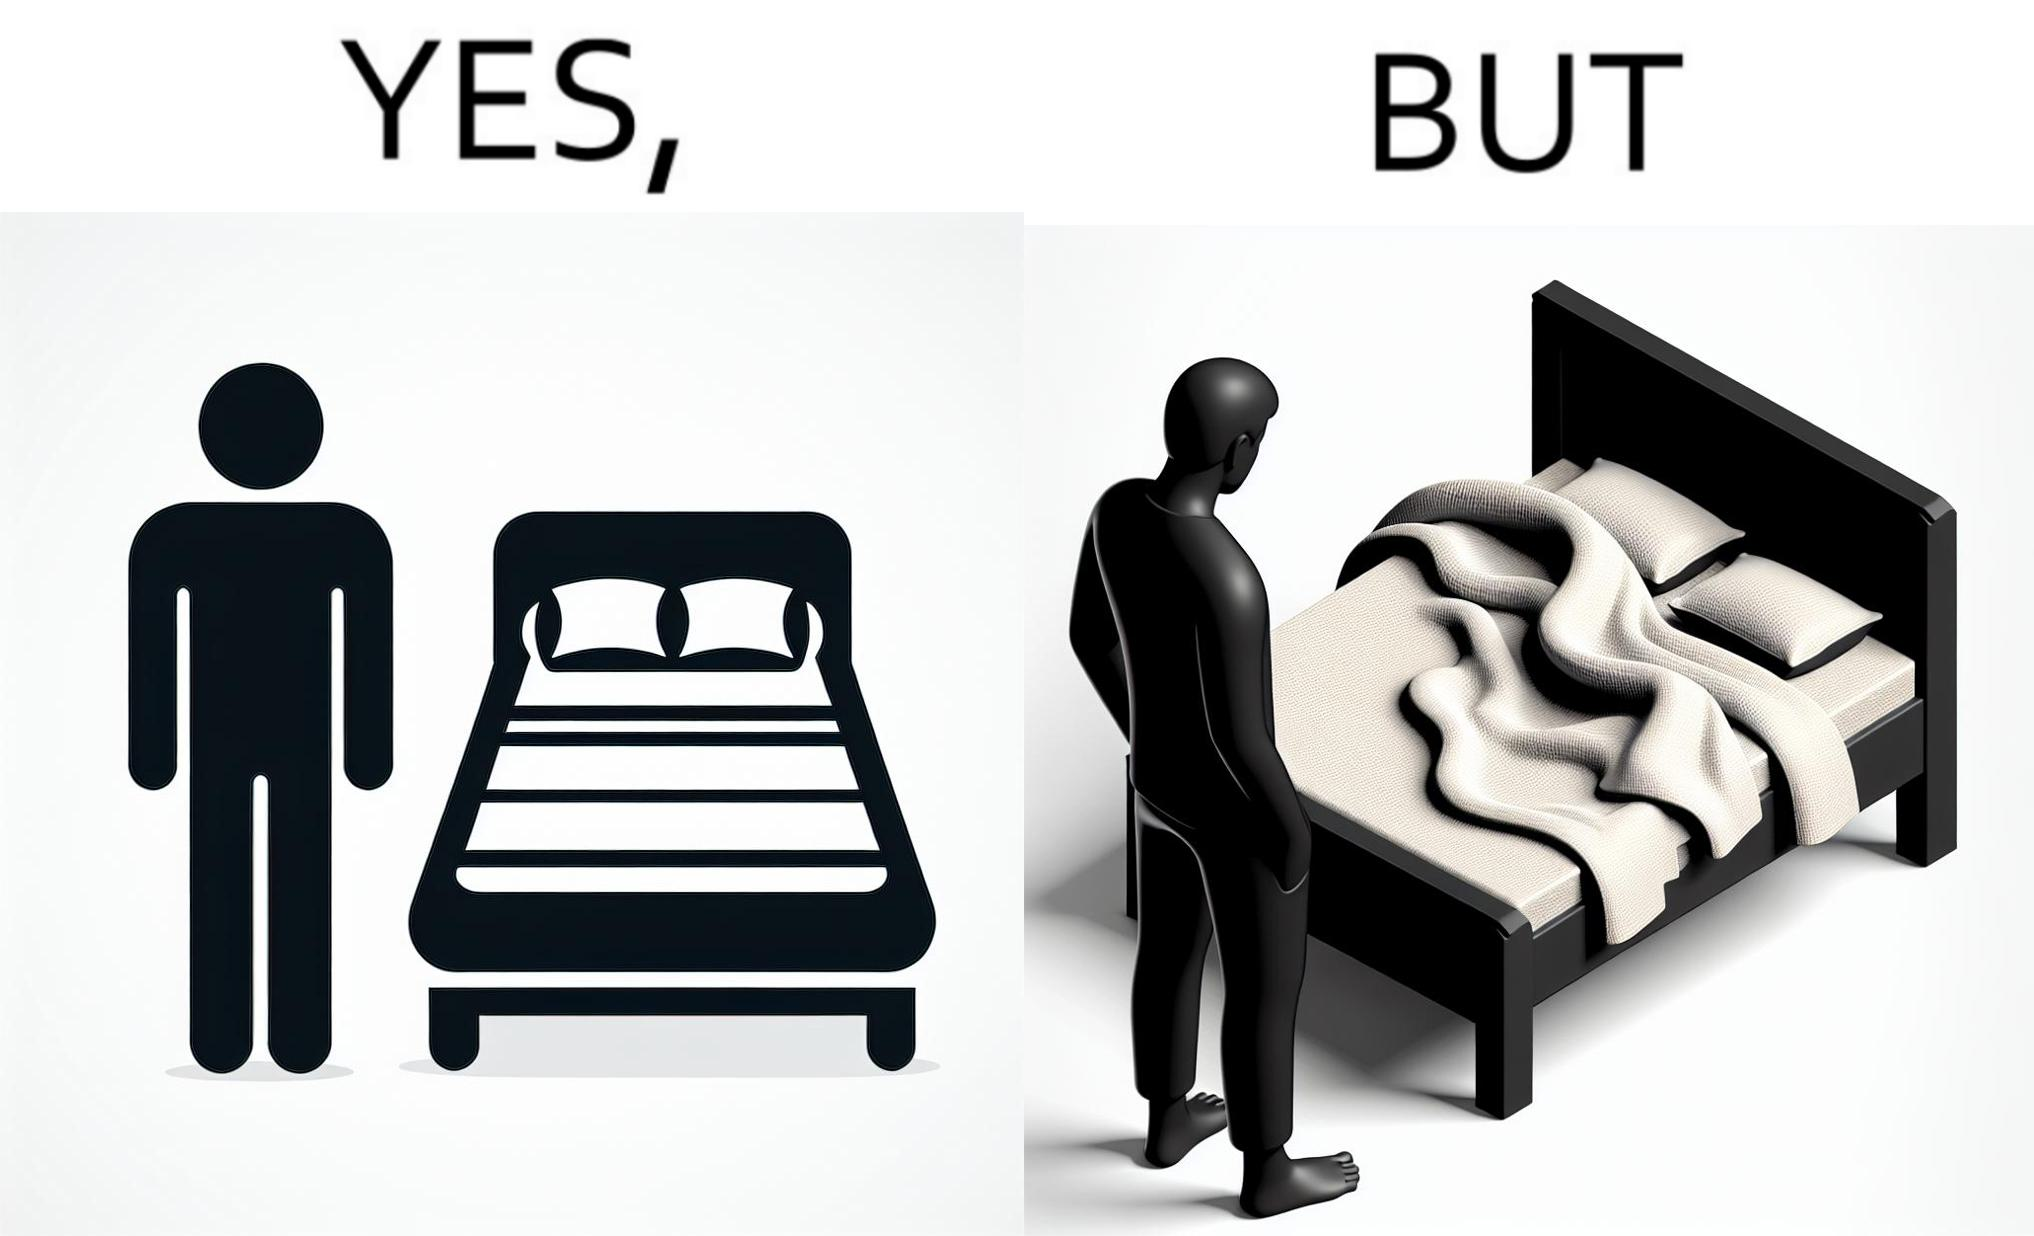Does this image contain satire or humor? Yes, this image is satirical. 